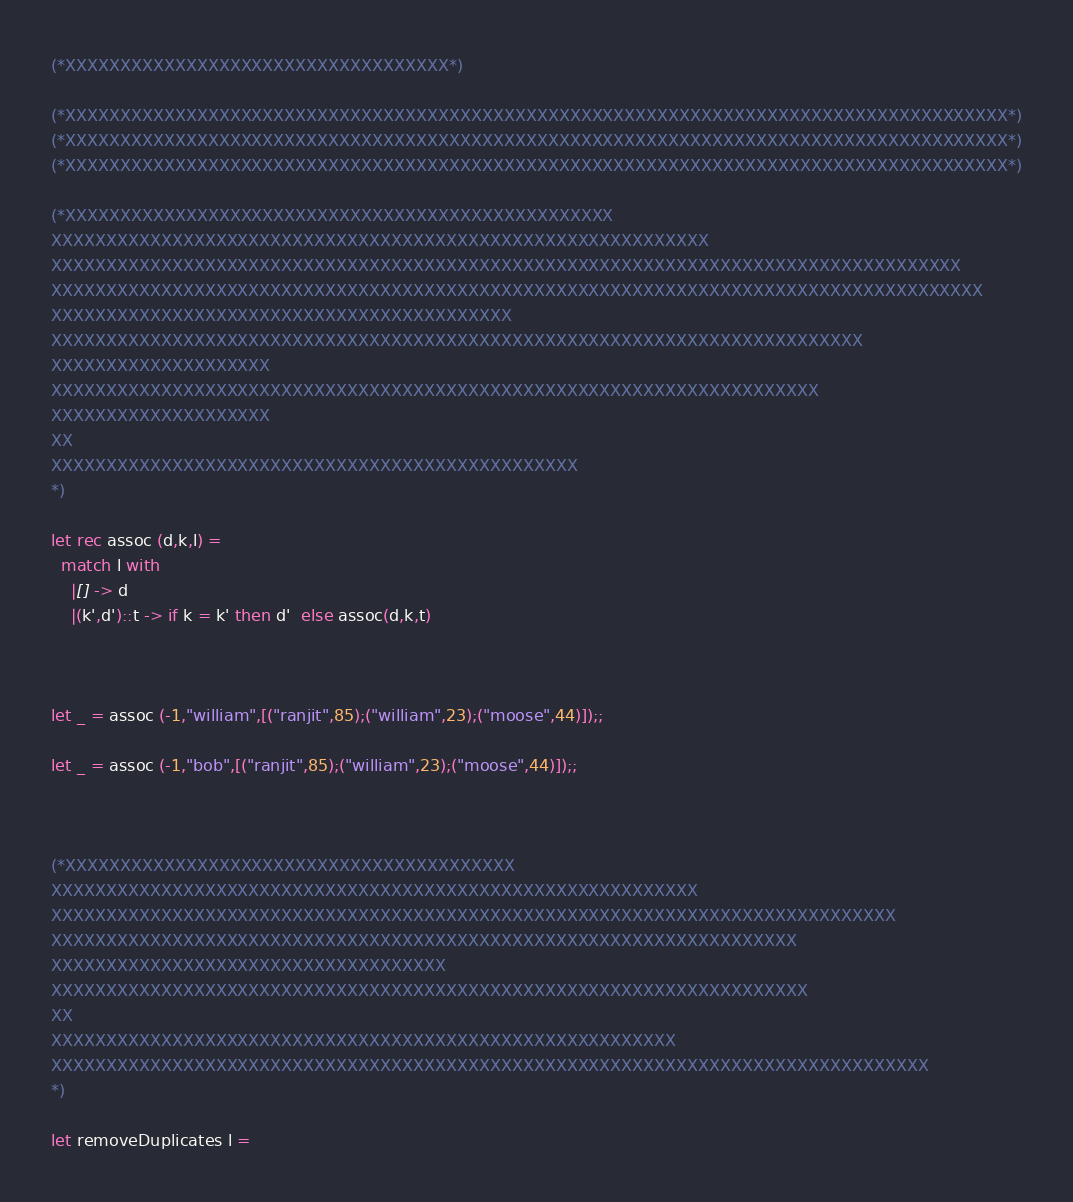Convert code to text. <code><loc_0><loc_0><loc_500><loc_500><_OCaml_>(*XXXXXXXXXXXXXXXXXXXXXXXXXXXXXXXXXXX*)

(*XXXXXXXXXXXXXXXXXXXXXXXXXXXXXXXXXXXXXXXXXXXXXXXXXXXXXXXXXXXXXXXXXXXXXXXXXXXXXXXXXXXXXX*)
(*XXXXXXXXXXXXXXXXXXXXXXXXXXXXXXXXXXXXXXXXXXXXXXXXXXXXXXXXXXXXXXXXXXXXXXXXXXXXXXXXXXXXXX*)
(*XXXXXXXXXXXXXXXXXXXXXXXXXXXXXXXXXXXXXXXXXXXXXXXXXXXXXXXXXXXXXXXXXXXXXXXXXXXXXXXXXXXXXX*)

(*XXXXXXXXXXXXXXXXXXXXXXXXXXXXXXXXXXXXXXXXXXXXXXXXXX
XXXXXXXXXXXXXXXXXXXXXXXXXXXXXXXXXXXXXXXXXXXXXXXXXXXXXXXXXXXX
XXXXXXXXXXXXXXXXXXXXXXXXXXXXXXXXXXXXXXXXXXXXXXXXXXXXXXXXXXXXXXXXXXXXXXXXXXXXXXXXXXX
XXXXXXXXXXXXXXXXXXXXXXXXXXXXXXXXXXXXXXXXXXXXXXXXXXXXXXXXXXXXXXXXXXXXXXXXXXXXXXXXXXXXX
XXXXXXXXXXXXXXXXXXXXXXXXXXXXXXXXXXXXXXXXXX
XXXXXXXXXXXXXXXXXXXXXXXXXXXXXXXXXXXXXXXXXXXXXXXXXXXXXXXXXXXXXXXXXXXXXXXXXX
XXXXXXXXXXXXXXXXXXXX
XXXXXXXXXXXXXXXXXXXXXXXXXXXXXXXXXXXXXXXXXXXXXXXXXXXXXXXXXXXXXXXXXXXXXX
XXXXXXXXXXXXXXXXXXXX
XX
XXXXXXXXXXXXXXXXXXXXXXXXXXXXXXXXXXXXXXXXXXXXXXXX
*)

let rec assoc (d,k,l) = 
  match l with
    |[] -> d
    |(k',d')::t -> if k = k' then d'  else assoc(d,k,t)



let _ = assoc (-1,"william",[("ranjit",85);("william",23);("moose",44)]);;    

let _ = assoc (-1,"bob",[("ranjit",85);("william",23);("moose",44)]);;



(*XXXXXXXXXXXXXXXXXXXXXXXXXXXXXXXXXXXXXXXXX
XXXXXXXXXXXXXXXXXXXXXXXXXXXXXXXXXXXXXXXXXXXXXXXXXXXXXXXXXXX
XXXXXXXXXXXXXXXXXXXXXXXXXXXXXXXXXXXXXXXXXXXXXXXXXXXXXXXXXXXXXXXXXXXXXXXXXXXXX
XXXXXXXXXXXXXXXXXXXXXXXXXXXXXXXXXXXXXXXXXXXXXXXXXXXXXXXXXXXXXXXXXXXX
XXXXXXXXXXXXXXXXXXXXXXXXXXXXXXXXXXXX
XXXXXXXXXXXXXXXXXXXXXXXXXXXXXXXXXXXXXXXXXXXXXXXXXXXXXXXXXXXXXXXXXXXXX
XX
XXXXXXXXXXXXXXXXXXXXXXXXXXXXXXXXXXXXXXXXXXXXXXXXXXXXXXXXX
XXXXXXXXXXXXXXXXXXXXXXXXXXXXXXXXXXXXXXXXXXXXXXXXXXXXXXXXXXXXXXXXXXXXXXXXXXXXXXXX
*)

let removeDuplicates l = </code> 